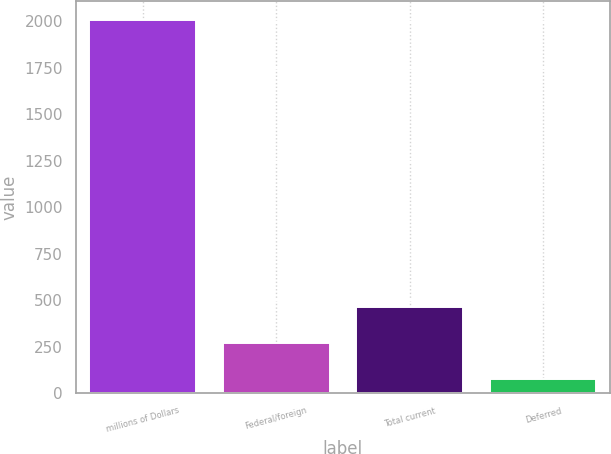Convert chart to OTSL. <chart><loc_0><loc_0><loc_500><loc_500><bar_chart><fcel>millions of Dollars<fcel>Federal/foreign<fcel>Total current<fcel>Deferred<nl><fcel>2008<fcel>268.21<fcel>461.52<fcel>74.9<nl></chart> 